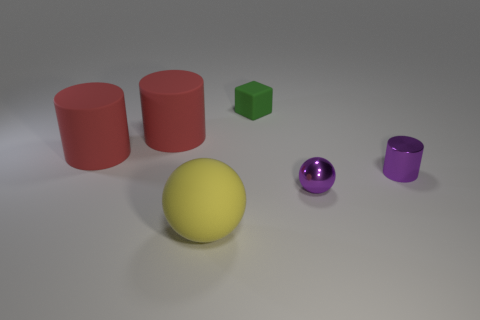There is a small thing that is the same material as the small purple ball; what color is it?
Your answer should be very brief. Purple. There is a large yellow matte thing; what shape is it?
Your answer should be very brief. Sphere. What number of other tiny cylinders have the same color as the shiny cylinder?
Give a very brief answer. 0. There is a purple object that is the same size as the metal ball; what shape is it?
Offer a very short reply. Cylinder. Is there a cyan rubber block that has the same size as the green rubber block?
Ensure brevity in your answer.  No. What material is the purple cylinder that is the same size as the green thing?
Your answer should be very brief. Metal. What size is the sphere that is on the left side of the matte thing that is on the right side of the yellow matte object?
Offer a very short reply. Large. Do the matte thing right of the yellow thing and the large yellow rubber thing have the same size?
Provide a succinct answer. No. Is the number of large things that are in front of the purple metal sphere greater than the number of large matte cylinders that are right of the small green object?
Provide a succinct answer. Yes. There is a object that is behind the tiny sphere and right of the small matte cube; what shape is it?
Your answer should be compact. Cylinder. 